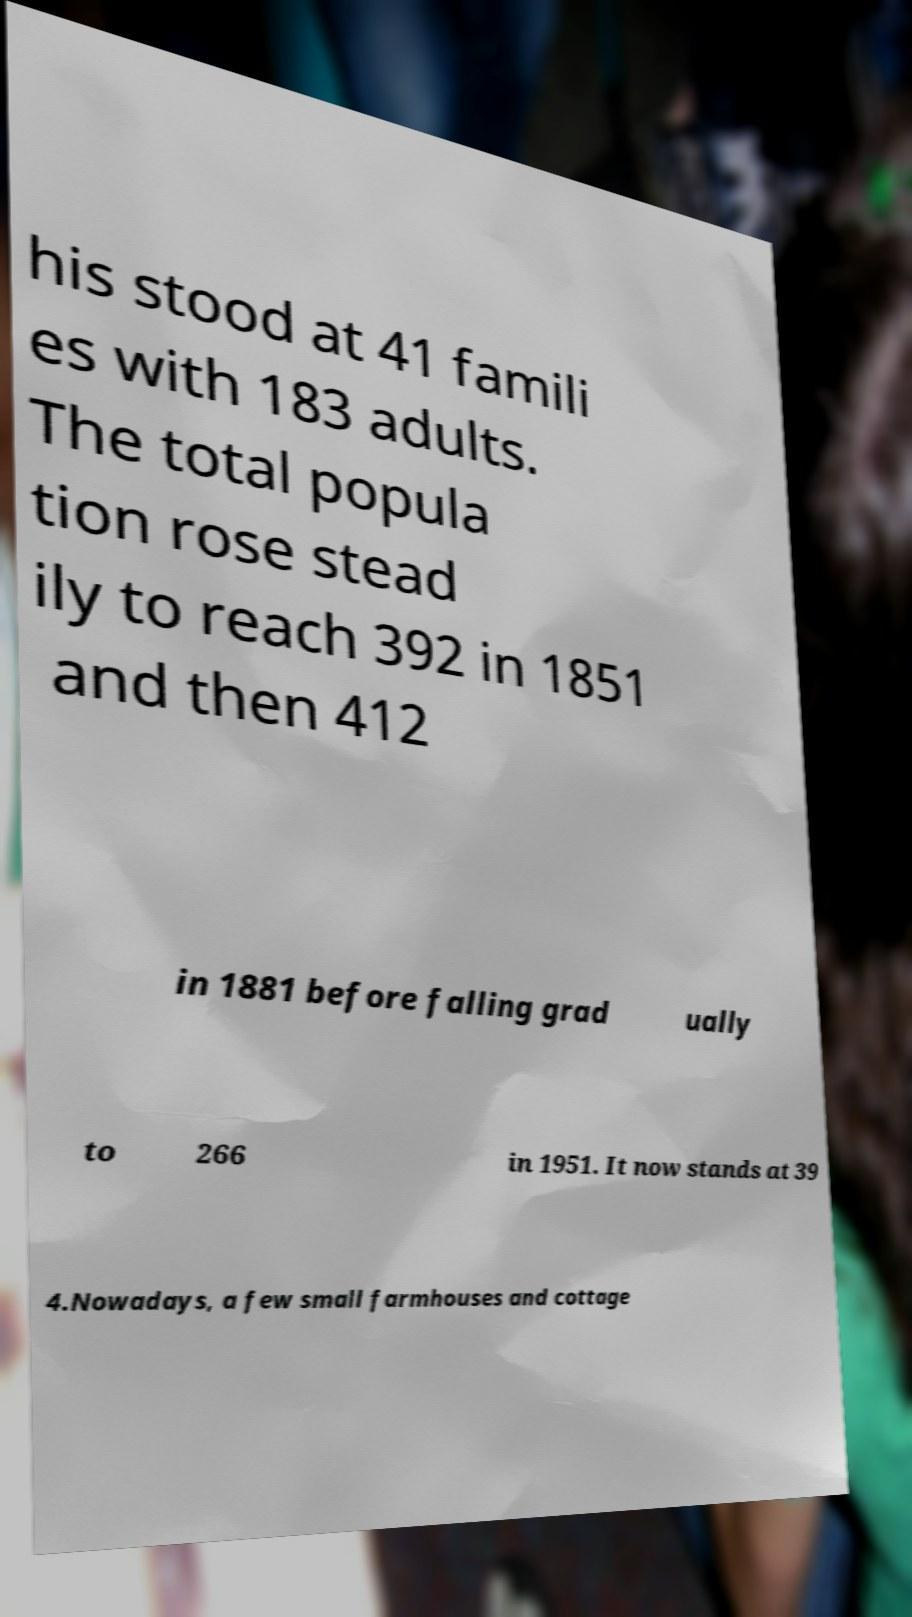What messages or text are displayed in this image? I need them in a readable, typed format. his stood at 41 famili es with 183 adults. The total popula tion rose stead ily to reach 392 in 1851 and then 412 in 1881 before falling grad ually to 266 in 1951. It now stands at 39 4.Nowadays, a few small farmhouses and cottage 